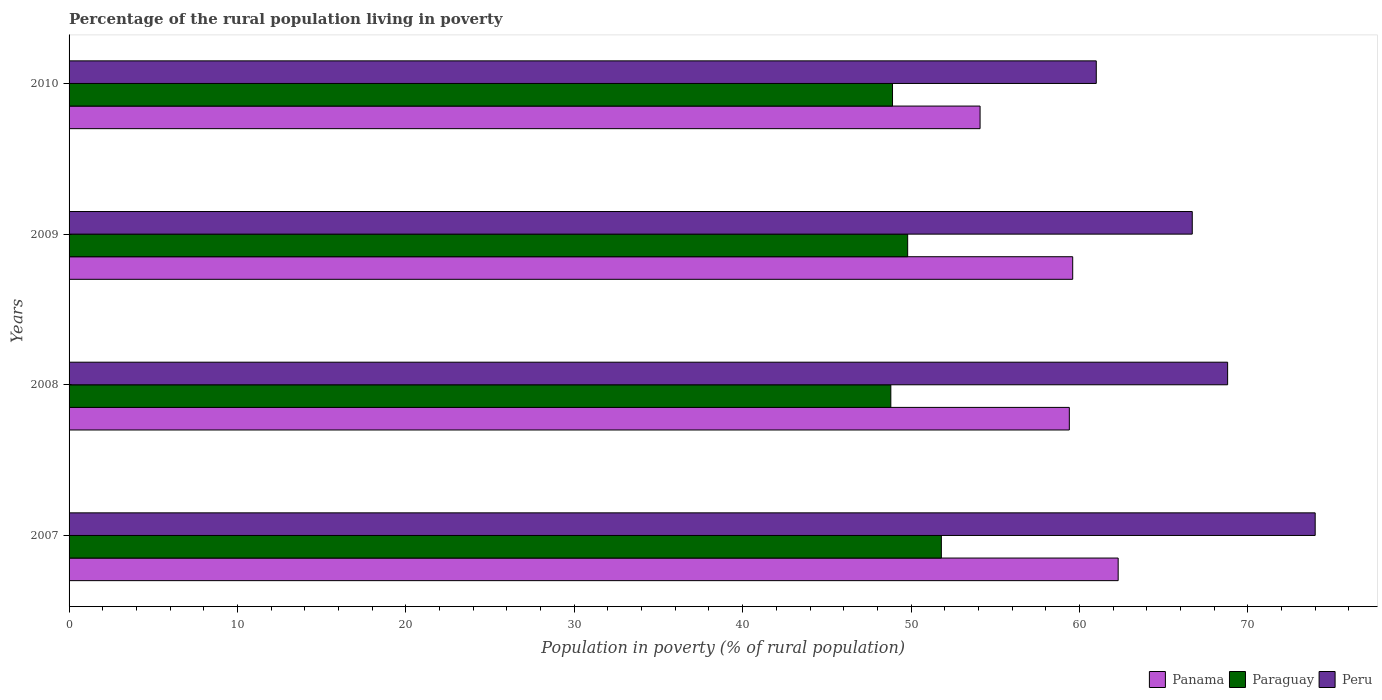Are the number of bars per tick equal to the number of legend labels?
Give a very brief answer. Yes. Are the number of bars on each tick of the Y-axis equal?
Make the answer very short. Yes. What is the label of the 3rd group of bars from the top?
Offer a very short reply. 2008. In how many cases, is the number of bars for a given year not equal to the number of legend labels?
Give a very brief answer. 0. What is the percentage of the rural population living in poverty in Panama in 2007?
Ensure brevity in your answer.  62.3. Across all years, what is the maximum percentage of the rural population living in poverty in Peru?
Give a very brief answer. 74. Across all years, what is the minimum percentage of the rural population living in poverty in Paraguay?
Your answer should be very brief. 48.8. In which year was the percentage of the rural population living in poverty in Paraguay maximum?
Give a very brief answer. 2007. In which year was the percentage of the rural population living in poverty in Paraguay minimum?
Offer a terse response. 2008. What is the total percentage of the rural population living in poverty in Paraguay in the graph?
Keep it short and to the point. 199.3. What is the difference between the percentage of the rural population living in poverty in Peru in 2008 and that in 2010?
Keep it short and to the point. 7.8. What is the difference between the percentage of the rural population living in poverty in Peru in 2008 and the percentage of the rural population living in poverty in Paraguay in 2007?
Provide a short and direct response. 17. What is the average percentage of the rural population living in poverty in Peru per year?
Your response must be concise. 67.62. In the year 2009, what is the difference between the percentage of the rural population living in poverty in Panama and percentage of the rural population living in poverty in Peru?
Make the answer very short. -7.1. In how many years, is the percentage of the rural population living in poverty in Peru greater than 70 %?
Provide a short and direct response. 1. What is the ratio of the percentage of the rural population living in poverty in Panama in 2008 to that in 2009?
Make the answer very short. 1. Is the percentage of the rural population living in poverty in Paraguay in 2007 less than that in 2008?
Offer a very short reply. No. What is the difference between the highest and the lowest percentage of the rural population living in poverty in Panama?
Your response must be concise. 8.2. In how many years, is the percentage of the rural population living in poverty in Panama greater than the average percentage of the rural population living in poverty in Panama taken over all years?
Provide a short and direct response. 3. Is the sum of the percentage of the rural population living in poverty in Paraguay in 2007 and 2008 greater than the maximum percentage of the rural population living in poverty in Panama across all years?
Provide a short and direct response. Yes. What does the 3rd bar from the top in 2010 represents?
Provide a succinct answer. Panama. What does the 2nd bar from the bottom in 2007 represents?
Give a very brief answer. Paraguay. Is it the case that in every year, the sum of the percentage of the rural population living in poverty in Peru and percentage of the rural population living in poverty in Paraguay is greater than the percentage of the rural population living in poverty in Panama?
Keep it short and to the point. Yes. How many bars are there?
Your response must be concise. 12. How many years are there in the graph?
Your answer should be compact. 4. What is the difference between two consecutive major ticks on the X-axis?
Provide a short and direct response. 10. Does the graph contain any zero values?
Your answer should be very brief. No. Does the graph contain grids?
Ensure brevity in your answer.  No. How many legend labels are there?
Provide a succinct answer. 3. How are the legend labels stacked?
Make the answer very short. Horizontal. What is the title of the graph?
Provide a short and direct response. Percentage of the rural population living in poverty. What is the label or title of the X-axis?
Offer a terse response. Population in poverty (% of rural population). What is the label or title of the Y-axis?
Make the answer very short. Years. What is the Population in poverty (% of rural population) of Panama in 2007?
Offer a terse response. 62.3. What is the Population in poverty (% of rural population) in Paraguay in 2007?
Offer a very short reply. 51.8. What is the Population in poverty (% of rural population) in Panama in 2008?
Ensure brevity in your answer.  59.4. What is the Population in poverty (% of rural population) in Paraguay in 2008?
Your answer should be compact. 48.8. What is the Population in poverty (% of rural population) of Peru in 2008?
Your response must be concise. 68.8. What is the Population in poverty (% of rural population) of Panama in 2009?
Offer a very short reply. 59.6. What is the Population in poverty (% of rural population) of Paraguay in 2009?
Offer a very short reply. 49.8. What is the Population in poverty (% of rural population) of Peru in 2009?
Your answer should be very brief. 66.7. What is the Population in poverty (% of rural population) in Panama in 2010?
Offer a very short reply. 54.1. What is the Population in poverty (% of rural population) in Paraguay in 2010?
Ensure brevity in your answer.  48.9. Across all years, what is the maximum Population in poverty (% of rural population) in Panama?
Provide a succinct answer. 62.3. Across all years, what is the maximum Population in poverty (% of rural population) of Paraguay?
Provide a succinct answer. 51.8. Across all years, what is the minimum Population in poverty (% of rural population) in Panama?
Keep it short and to the point. 54.1. Across all years, what is the minimum Population in poverty (% of rural population) in Paraguay?
Give a very brief answer. 48.8. Across all years, what is the minimum Population in poverty (% of rural population) in Peru?
Your answer should be very brief. 61. What is the total Population in poverty (% of rural population) in Panama in the graph?
Your answer should be very brief. 235.4. What is the total Population in poverty (% of rural population) of Paraguay in the graph?
Ensure brevity in your answer.  199.3. What is the total Population in poverty (% of rural population) in Peru in the graph?
Your response must be concise. 270.5. What is the difference between the Population in poverty (% of rural population) of Panama in 2007 and that in 2008?
Ensure brevity in your answer.  2.9. What is the difference between the Population in poverty (% of rural population) of Paraguay in 2007 and that in 2008?
Your answer should be compact. 3. What is the difference between the Population in poverty (% of rural population) of Peru in 2007 and that in 2008?
Your answer should be very brief. 5.2. What is the difference between the Population in poverty (% of rural population) of Panama in 2007 and that in 2009?
Your response must be concise. 2.7. What is the difference between the Population in poverty (% of rural population) of Peru in 2007 and that in 2009?
Keep it short and to the point. 7.3. What is the difference between the Population in poverty (% of rural population) of Panama in 2008 and that in 2009?
Ensure brevity in your answer.  -0.2. What is the difference between the Population in poverty (% of rural population) in Paraguay in 2008 and that in 2009?
Your answer should be very brief. -1. What is the difference between the Population in poverty (% of rural population) of Paraguay in 2008 and that in 2010?
Your response must be concise. -0.1. What is the difference between the Population in poverty (% of rural population) in Panama in 2009 and that in 2010?
Your answer should be compact. 5.5. What is the difference between the Population in poverty (% of rural population) in Paraguay in 2009 and that in 2010?
Ensure brevity in your answer.  0.9. What is the difference between the Population in poverty (% of rural population) in Peru in 2009 and that in 2010?
Your response must be concise. 5.7. What is the difference between the Population in poverty (% of rural population) in Panama in 2007 and the Population in poverty (% of rural population) in Peru in 2008?
Your answer should be compact. -6.5. What is the difference between the Population in poverty (% of rural population) in Panama in 2007 and the Population in poverty (% of rural population) in Peru in 2009?
Your answer should be compact. -4.4. What is the difference between the Population in poverty (% of rural population) in Paraguay in 2007 and the Population in poverty (% of rural population) in Peru in 2009?
Ensure brevity in your answer.  -14.9. What is the difference between the Population in poverty (% of rural population) in Panama in 2007 and the Population in poverty (% of rural population) in Paraguay in 2010?
Your answer should be very brief. 13.4. What is the difference between the Population in poverty (% of rural population) in Panama in 2007 and the Population in poverty (% of rural population) in Peru in 2010?
Offer a terse response. 1.3. What is the difference between the Population in poverty (% of rural population) in Panama in 2008 and the Population in poverty (% of rural population) in Peru in 2009?
Ensure brevity in your answer.  -7.3. What is the difference between the Population in poverty (% of rural population) in Paraguay in 2008 and the Population in poverty (% of rural population) in Peru in 2009?
Your answer should be very brief. -17.9. What is the difference between the Population in poverty (% of rural population) in Panama in 2008 and the Population in poverty (% of rural population) in Peru in 2010?
Keep it short and to the point. -1.6. What is the difference between the Population in poverty (% of rural population) in Paraguay in 2008 and the Population in poverty (% of rural population) in Peru in 2010?
Your answer should be compact. -12.2. What is the difference between the Population in poverty (% of rural population) in Panama in 2009 and the Population in poverty (% of rural population) in Paraguay in 2010?
Provide a succinct answer. 10.7. What is the difference between the Population in poverty (% of rural population) in Paraguay in 2009 and the Population in poverty (% of rural population) in Peru in 2010?
Keep it short and to the point. -11.2. What is the average Population in poverty (% of rural population) in Panama per year?
Keep it short and to the point. 58.85. What is the average Population in poverty (% of rural population) in Paraguay per year?
Provide a short and direct response. 49.83. What is the average Population in poverty (% of rural population) in Peru per year?
Your answer should be compact. 67.62. In the year 2007, what is the difference between the Population in poverty (% of rural population) in Panama and Population in poverty (% of rural population) in Peru?
Ensure brevity in your answer.  -11.7. In the year 2007, what is the difference between the Population in poverty (% of rural population) of Paraguay and Population in poverty (% of rural population) of Peru?
Provide a succinct answer. -22.2. In the year 2008, what is the difference between the Population in poverty (% of rural population) of Panama and Population in poverty (% of rural population) of Paraguay?
Your answer should be very brief. 10.6. In the year 2008, what is the difference between the Population in poverty (% of rural population) of Panama and Population in poverty (% of rural population) of Peru?
Give a very brief answer. -9.4. In the year 2008, what is the difference between the Population in poverty (% of rural population) in Paraguay and Population in poverty (% of rural population) in Peru?
Provide a short and direct response. -20. In the year 2009, what is the difference between the Population in poverty (% of rural population) in Panama and Population in poverty (% of rural population) in Peru?
Offer a terse response. -7.1. In the year 2009, what is the difference between the Population in poverty (% of rural population) in Paraguay and Population in poverty (% of rural population) in Peru?
Your answer should be compact. -16.9. What is the ratio of the Population in poverty (% of rural population) in Panama in 2007 to that in 2008?
Give a very brief answer. 1.05. What is the ratio of the Population in poverty (% of rural population) of Paraguay in 2007 to that in 2008?
Provide a short and direct response. 1.06. What is the ratio of the Population in poverty (% of rural population) of Peru in 2007 to that in 2008?
Offer a very short reply. 1.08. What is the ratio of the Population in poverty (% of rural population) of Panama in 2007 to that in 2009?
Offer a very short reply. 1.05. What is the ratio of the Population in poverty (% of rural population) in Paraguay in 2007 to that in 2009?
Offer a terse response. 1.04. What is the ratio of the Population in poverty (% of rural population) of Peru in 2007 to that in 2009?
Ensure brevity in your answer.  1.11. What is the ratio of the Population in poverty (% of rural population) of Panama in 2007 to that in 2010?
Keep it short and to the point. 1.15. What is the ratio of the Population in poverty (% of rural population) of Paraguay in 2007 to that in 2010?
Give a very brief answer. 1.06. What is the ratio of the Population in poverty (% of rural population) in Peru in 2007 to that in 2010?
Your response must be concise. 1.21. What is the ratio of the Population in poverty (% of rural population) of Panama in 2008 to that in 2009?
Keep it short and to the point. 1. What is the ratio of the Population in poverty (% of rural population) in Paraguay in 2008 to that in 2009?
Keep it short and to the point. 0.98. What is the ratio of the Population in poverty (% of rural population) in Peru in 2008 to that in 2009?
Offer a very short reply. 1.03. What is the ratio of the Population in poverty (% of rural population) of Panama in 2008 to that in 2010?
Your response must be concise. 1.1. What is the ratio of the Population in poverty (% of rural population) of Peru in 2008 to that in 2010?
Provide a succinct answer. 1.13. What is the ratio of the Population in poverty (% of rural population) in Panama in 2009 to that in 2010?
Offer a very short reply. 1.1. What is the ratio of the Population in poverty (% of rural population) of Paraguay in 2009 to that in 2010?
Make the answer very short. 1.02. What is the ratio of the Population in poverty (% of rural population) of Peru in 2009 to that in 2010?
Provide a short and direct response. 1.09. What is the difference between the highest and the second highest Population in poverty (% of rural population) in Paraguay?
Your answer should be compact. 2. What is the difference between the highest and the second highest Population in poverty (% of rural population) of Peru?
Offer a terse response. 5.2. What is the difference between the highest and the lowest Population in poverty (% of rural population) of Panama?
Your response must be concise. 8.2. 